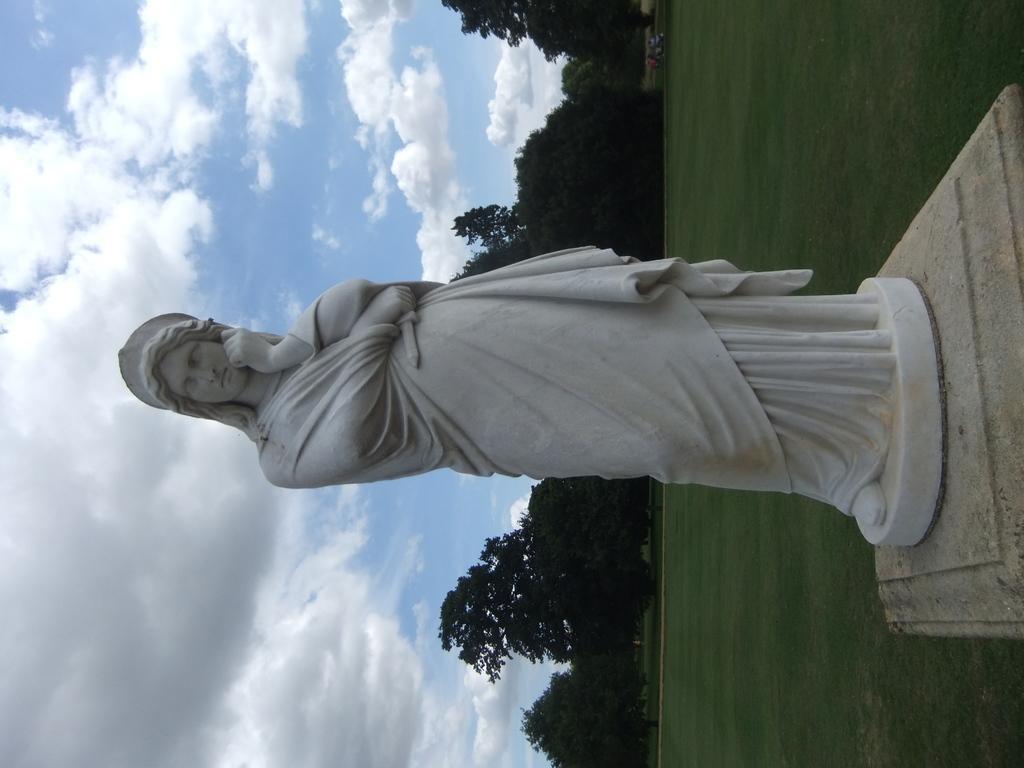Can you describe this image briefly? In the center of the image a statue is there. In the middle of the image a trees are present. On the left side of the image clouds are present in the sky. On the right side of the image ground is there. 